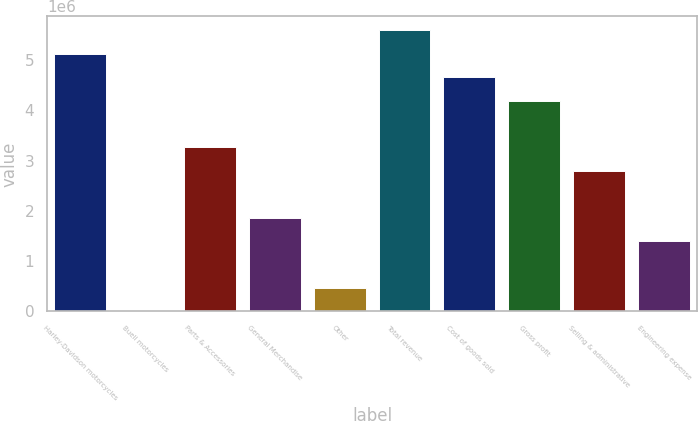Convert chart to OTSL. <chart><loc_0><loc_0><loc_500><loc_500><bar_chart><fcel>Harley-Davidson motorcycles<fcel>Buell motorcycles<fcel>Parts & Accessories<fcel>General Merchandise<fcel>Other<fcel>Total revenue<fcel>Cost of goods sold<fcel>Gross profit<fcel>Selling & administrative<fcel>Engineering expense<nl><fcel>5.12836e+06<fcel>1256<fcel>3.26396e+06<fcel>1.86566e+06<fcel>467357<fcel>5.59447e+06<fcel>4.66226e+06<fcel>4.19616e+06<fcel>2.79786e+06<fcel>1.39956e+06<nl></chart> 